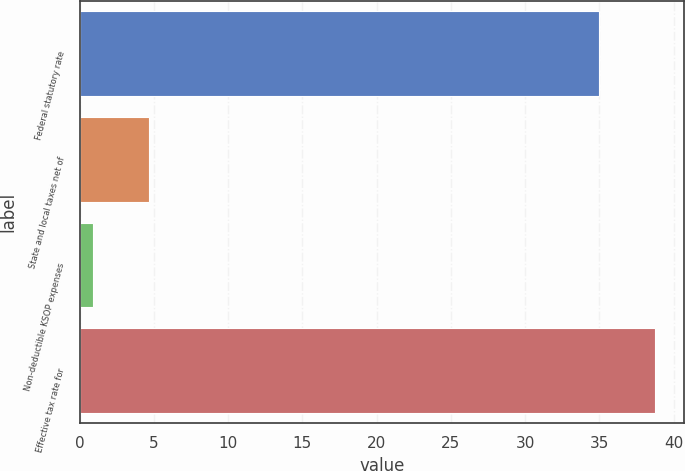<chart> <loc_0><loc_0><loc_500><loc_500><bar_chart><fcel>Federal statutory rate<fcel>State and local taxes net of<fcel>Non-deductible KSOP expenses<fcel>Effective tax rate for<nl><fcel>35<fcel>4.67<fcel>0.9<fcel>38.77<nl></chart> 